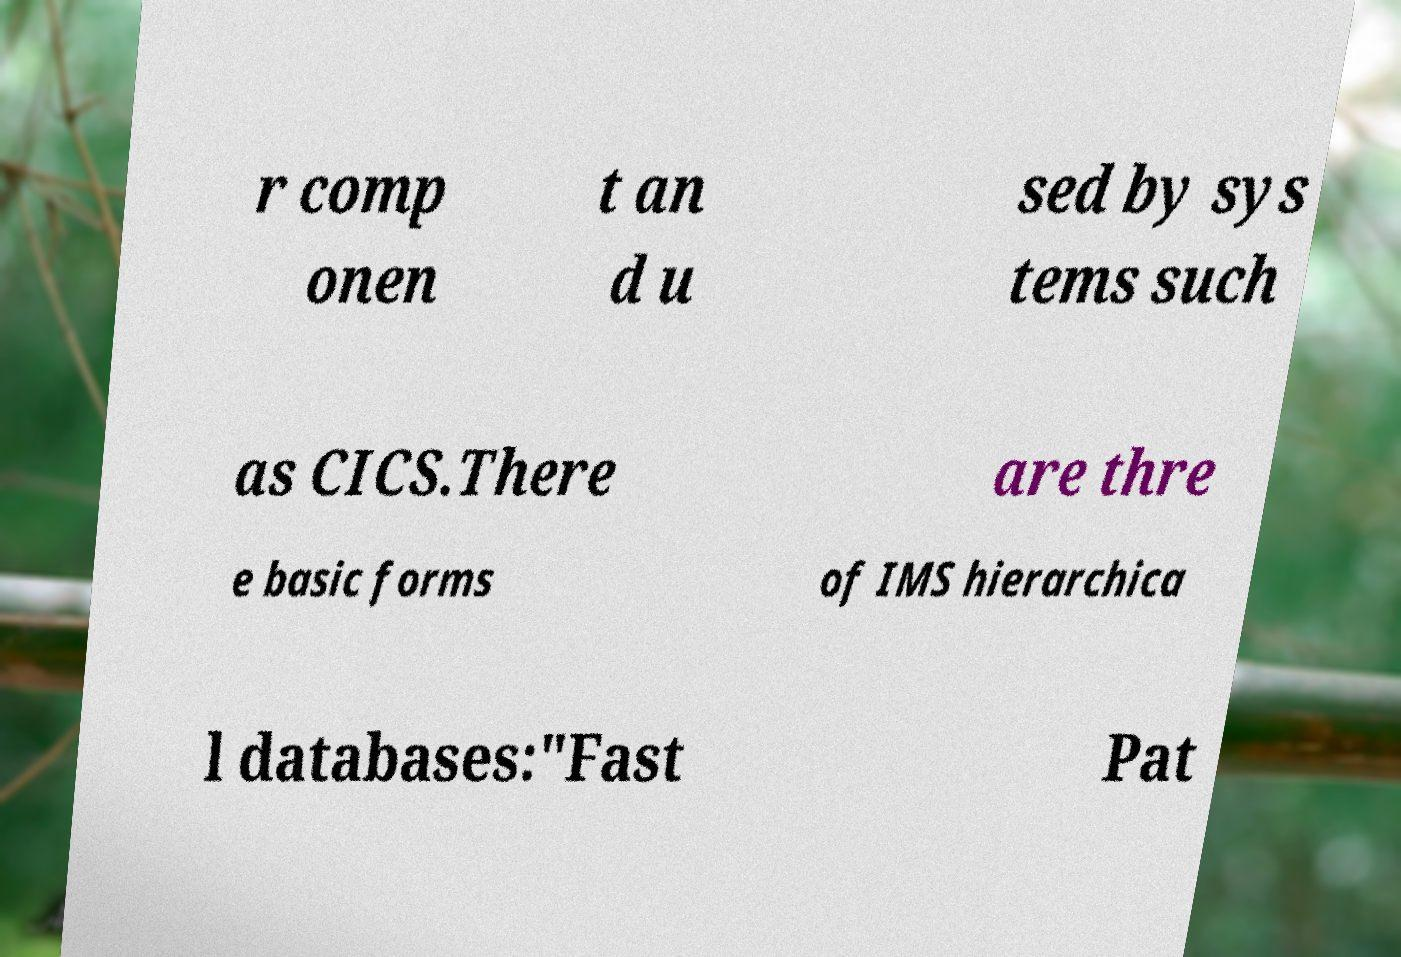There's text embedded in this image that I need extracted. Can you transcribe it verbatim? r comp onen t an d u sed by sys tems such as CICS.There are thre e basic forms of IMS hierarchica l databases:"Fast Pat 